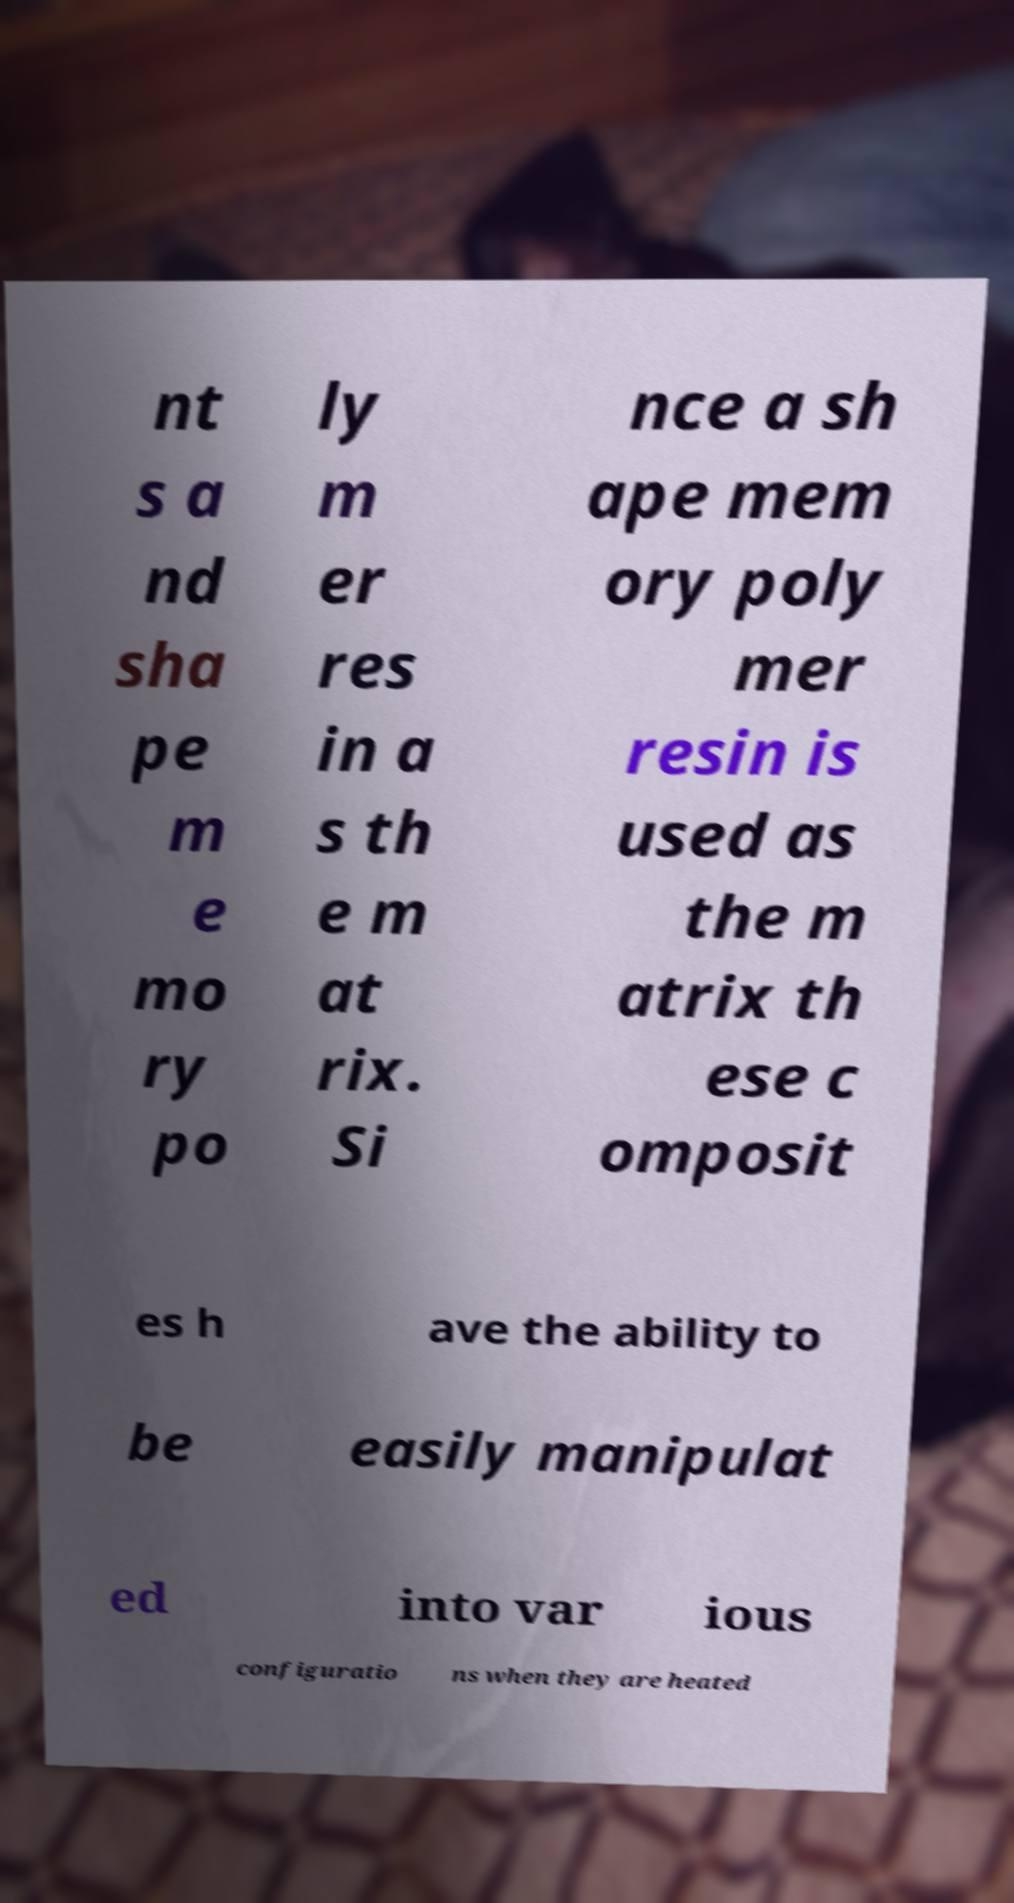I need the written content from this picture converted into text. Can you do that? nt s a nd sha pe m e mo ry po ly m er res in a s th e m at rix. Si nce a sh ape mem ory poly mer resin is used as the m atrix th ese c omposit es h ave the ability to be easily manipulat ed into var ious configuratio ns when they are heated 